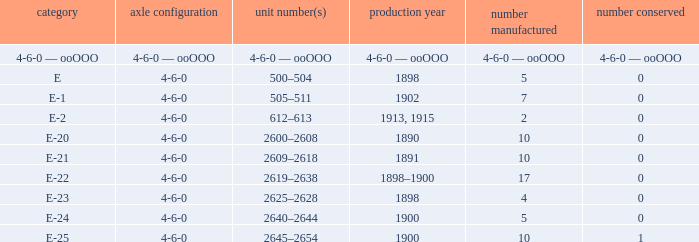What is the quantity made of the e-22 class, which has a quantity preserved of 0? 17.0. 